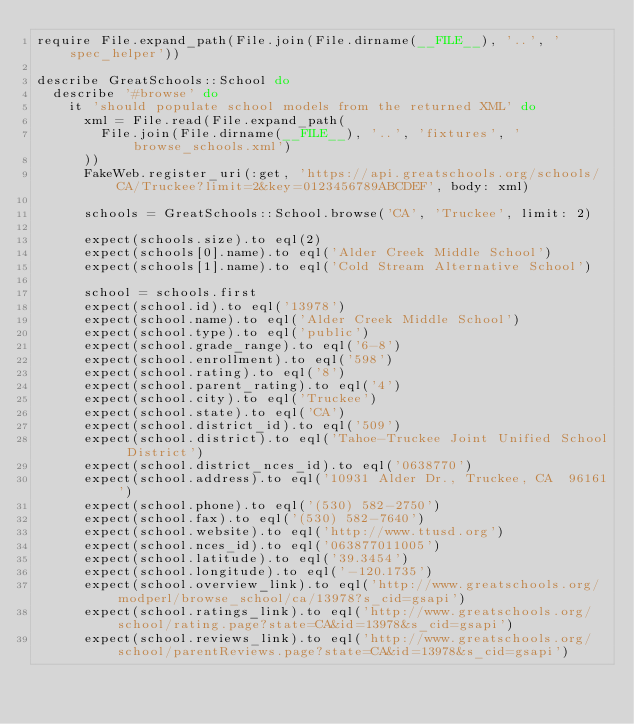<code> <loc_0><loc_0><loc_500><loc_500><_Ruby_>require File.expand_path(File.join(File.dirname(__FILE__), '..', 'spec_helper'))

describe GreatSchools::School do
  describe '#browse' do
    it 'should populate school models from the returned XML' do
      xml = File.read(File.expand_path(
        File.join(File.dirname(__FILE__), '..', 'fixtures', 'browse_schools.xml')
      ))
      FakeWeb.register_uri(:get, 'https://api.greatschools.org/schools/CA/Truckee?limit=2&key=0123456789ABCDEF', body: xml)

      schools = GreatSchools::School.browse('CA', 'Truckee', limit: 2)

      expect(schools.size).to eql(2)
      expect(schools[0].name).to eql('Alder Creek Middle School')
      expect(schools[1].name).to eql('Cold Stream Alternative School')

      school = schools.first
      expect(school.id).to eql('13978')
      expect(school.name).to eql('Alder Creek Middle School')
      expect(school.type).to eql('public')
      expect(school.grade_range).to eql('6-8')
      expect(school.enrollment).to eql('598')
      expect(school.rating).to eql('8')
      expect(school.parent_rating).to eql('4')
      expect(school.city).to eql('Truckee')
      expect(school.state).to eql('CA')
      expect(school.district_id).to eql('509')
      expect(school.district).to eql('Tahoe-Truckee Joint Unified School District')
      expect(school.district_nces_id).to eql('0638770')
      expect(school.address).to eql('10931 Alder Dr., Truckee, CA  96161')
      expect(school.phone).to eql('(530) 582-2750')
      expect(school.fax).to eql('(530) 582-7640')
      expect(school.website).to eql('http://www.ttusd.org')
      expect(school.nces_id).to eql('063877011005')
      expect(school.latitude).to eql('39.3454')
      expect(school.longitude).to eql('-120.1735')
      expect(school.overview_link).to eql('http://www.greatschools.org/modperl/browse_school/ca/13978?s_cid=gsapi')
      expect(school.ratings_link).to eql('http://www.greatschools.org/school/rating.page?state=CA&id=13978&s_cid=gsapi')
      expect(school.reviews_link).to eql('http://www.greatschools.org/school/parentReviews.page?state=CA&id=13978&s_cid=gsapi')</code> 